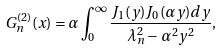<formula> <loc_0><loc_0><loc_500><loc_500>G _ { n } ^ { ( 2 ) } ( x ) = \alpha \int _ { 0 } ^ { \infty } \frac { J _ { 1 } ( y ) J _ { 0 } ( \alpha y ) d y } { \lambda _ { n } ^ { 2 } - \alpha ^ { 2 } y ^ { 2 } } ,</formula> 